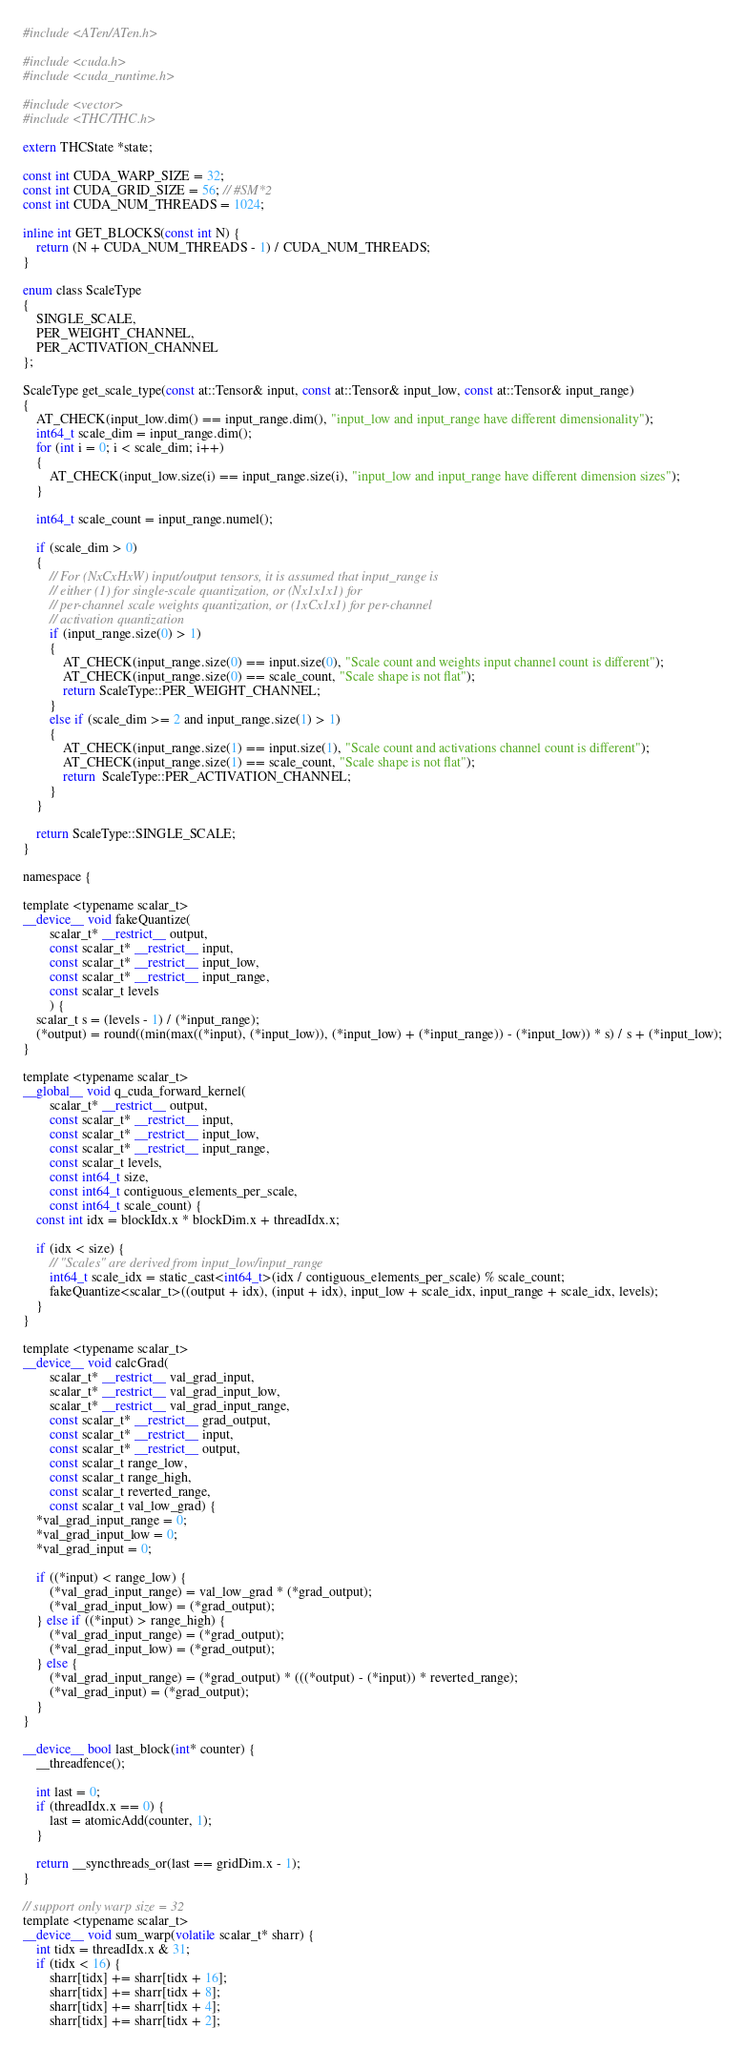<code> <loc_0><loc_0><loc_500><loc_500><_Cuda_>#include <ATen/ATen.h>

#include <cuda.h>
#include <cuda_runtime.h>

#include <vector>
#include <THC/THC.h>

extern THCState *state;

const int CUDA_WARP_SIZE = 32;
const int CUDA_GRID_SIZE = 56; // #SM*2
const int CUDA_NUM_THREADS = 1024;

inline int GET_BLOCKS(const int N) {
    return (N + CUDA_NUM_THREADS - 1) / CUDA_NUM_THREADS;
}

enum class ScaleType
{
    SINGLE_SCALE,
    PER_WEIGHT_CHANNEL,
    PER_ACTIVATION_CHANNEL
};

ScaleType get_scale_type(const at::Tensor& input, const at::Tensor& input_low, const at::Tensor& input_range)
{
    AT_CHECK(input_low.dim() == input_range.dim(), "input_low and input_range have different dimensionality");
    int64_t scale_dim = input_range.dim();
    for (int i = 0; i < scale_dim; i++)
    {
        AT_CHECK(input_low.size(i) == input_range.size(i), "input_low and input_range have different dimension sizes");
    }

    int64_t scale_count = input_range.numel();

    if (scale_dim > 0)
    {
        // For (NxCxHxW) input/output tensors, it is assumed that input_range is
        // either (1) for single-scale quantization, or (Nx1x1x1) for
        // per-channel scale weights quantization, or (1xCx1x1) for per-channel
        // activation quantization
        if (input_range.size(0) > 1)
        {
            AT_CHECK(input_range.size(0) == input.size(0), "Scale count and weights input channel count is different");
            AT_CHECK(input_range.size(0) == scale_count, "Scale shape is not flat");
            return ScaleType::PER_WEIGHT_CHANNEL;
        }
        else if (scale_dim >= 2 and input_range.size(1) > 1)
        {
            AT_CHECK(input_range.size(1) == input.size(1), "Scale count and activations channel count is different");
            AT_CHECK(input_range.size(1) == scale_count, "Scale shape is not flat");
            return  ScaleType::PER_ACTIVATION_CHANNEL;
        }
    }

    return ScaleType::SINGLE_SCALE;
}

namespace {

template <typename scalar_t>
__device__ void fakeQuantize(
        scalar_t* __restrict__ output,
        const scalar_t* __restrict__ input,
        const scalar_t* __restrict__ input_low,
        const scalar_t* __restrict__ input_range,
        const scalar_t levels
        ) {
    scalar_t s = (levels - 1) / (*input_range);
    (*output) = round((min(max((*input), (*input_low)), (*input_low) + (*input_range)) - (*input_low)) * s) / s + (*input_low);
}

template <typename scalar_t>
__global__ void q_cuda_forward_kernel(
        scalar_t* __restrict__ output,
        const scalar_t* __restrict__ input,
        const scalar_t* __restrict__ input_low,
        const scalar_t* __restrict__ input_range,
        const scalar_t levels,
        const int64_t size,
        const int64_t contiguous_elements_per_scale,
        const int64_t scale_count) {
    const int idx = blockIdx.x * blockDim.x + threadIdx.x;

    if (idx < size) {
        // "Scales" are derived from input_low/input_range
        int64_t scale_idx = static_cast<int64_t>(idx / contiguous_elements_per_scale) % scale_count;
        fakeQuantize<scalar_t>((output + idx), (input + idx), input_low + scale_idx, input_range + scale_idx, levels);
    }
}

template <typename scalar_t>
__device__ void calcGrad(
        scalar_t* __restrict__ val_grad_input,
        scalar_t* __restrict__ val_grad_input_low,
        scalar_t* __restrict__ val_grad_input_range,
        const scalar_t* __restrict__ grad_output,
        const scalar_t* __restrict__ input,
        const scalar_t* __restrict__ output,
        const scalar_t range_low,
        const scalar_t range_high,
        const scalar_t reverted_range,
        const scalar_t val_low_grad) {
    *val_grad_input_range = 0;
    *val_grad_input_low = 0;
    *val_grad_input = 0;

    if ((*input) < range_low) {
        (*val_grad_input_range) = val_low_grad * (*grad_output);
        (*val_grad_input_low) = (*grad_output);
    } else if ((*input) > range_high) {
        (*val_grad_input_range) = (*grad_output);
        (*val_grad_input_low) = (*grad_output);
    } else {
        (*val_grad_input_range) = (*grad_output) * (((*output) - (*input)) * reverted_range);
        (*val_grad_input) = (*grad_output);
    }
}

__device__ bool last_block(int* counter) {
    __threadfence();

    int last = 0;
    if (threadIdx.x == 0) {
        last = atomicAdd(counter, 1);
    }

    return __syncthreads_or(last == gridDim.x - 1);
}

// support only warp size = 32
template <typename scalar_t>
__device__ void sum_warp(volatile scalar_t* sharr) {
    int tidx = threadIdx.x & 31;
    if (tidx < 16) {
        sharr[tidx] += sharr[tidx + 16];
        sharr[tidx] += sharr[tidx + 8];
        sharr[tidx] += sharr[tidx + 4];
        sharr[tidx] += sharr[tidx + 2];</code> 